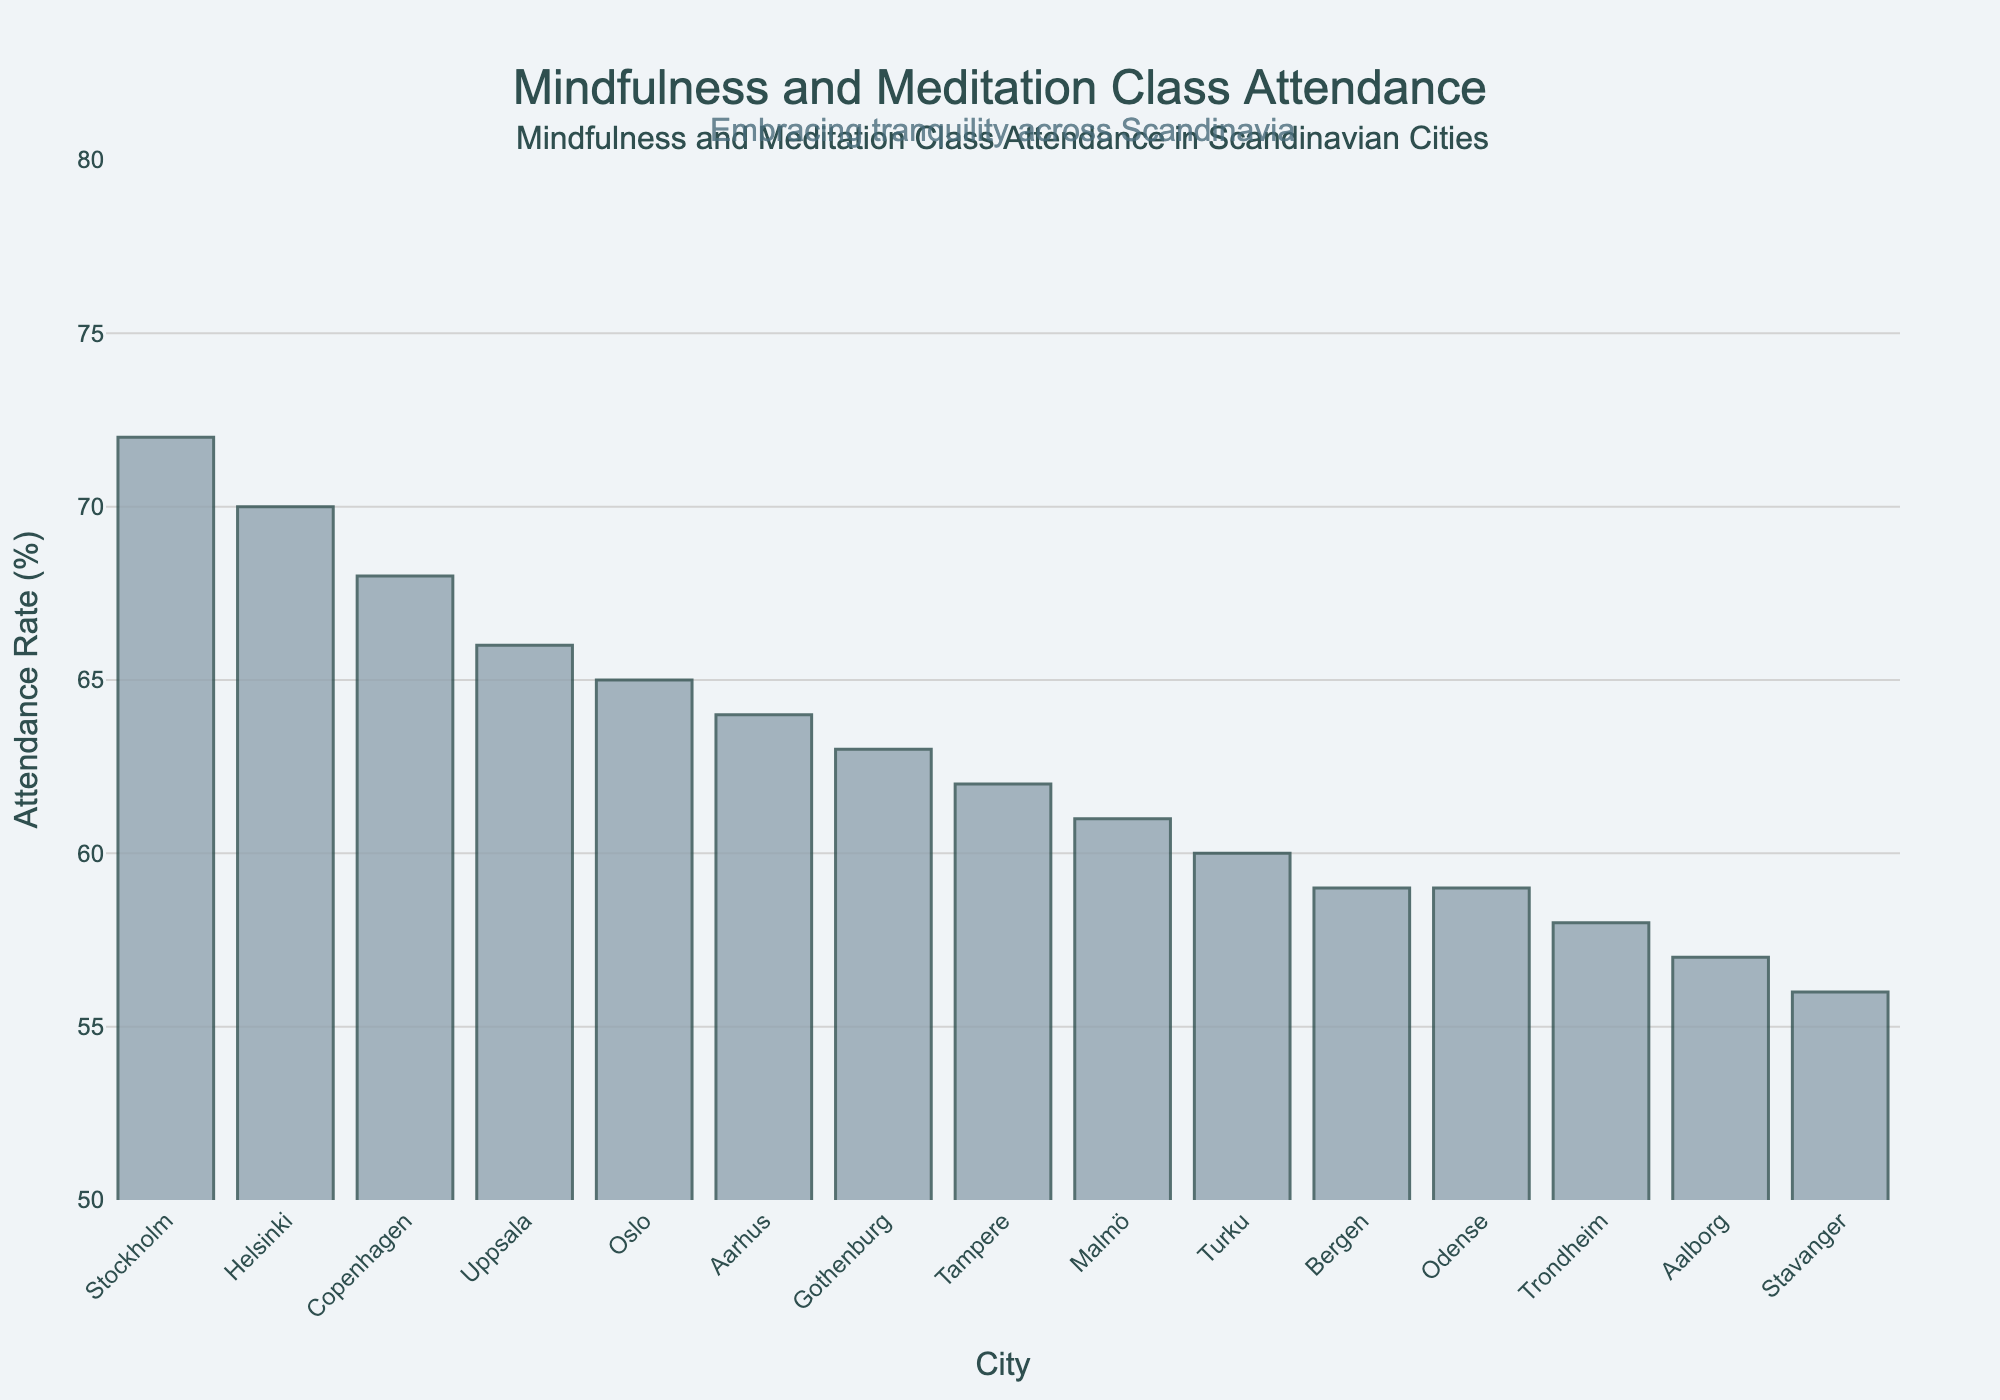Which city has the highest attendance rate? The bar that is the tallest in the figure represents the city with the highest attendance rate.
Answer: Stockholm Which city has the lowest attendance rate? The bar that is the shortest in the figure represents the city with the lowest attendance rate.
Answer: Aalborg What's the difference in attendance rate between Stockholm and Aalborg? The attendance rate for Stockholm is 72%, and for Aalborg, it is 57%. The difference is 72 - 57.
Answer: 15% Which cities have an attendance rate above 65%? The bars taller than the 65% mark represent cities with an attendance rate above 65%. These cities are identified as Copenhagen, Stockholm, Helsinki, and Uppsala.
Answer: Copenhagen, Stockholm, Helsinki, Uppsala What's the average attendance rate of the top 5 cities? The top 5 attendance rates are associated with the tallest bars: 72% (Stockholm), 70% (Helsinki), 68% (Copenhagen), 66% (Uppsala), and 65% (Oslo). The average can be calculated as (72 + 70 + 68 + 66 + 65) / 5.
Answer: 68.2% What's the median attendance rate of all cities? To find the median, first list out all 15 attendance rates in order: 56, 57, 58, 59, 59, 60, 61, 62, 63, 64, 65, 66, 68, 70, 72. The median attendance rate is the 8th value.
Answer: 62% Is there any city with an attendance rate exactly 60%? Look for the bar with an attendance rate labeled as 60%.
Answer: Turku How many cities have an attendance rate below 60%? Count the number of bars that are shorter than the 60% mark.
Answer: 4 Which cities have attendance rates between 60% and 70%? Identify the bars with heights falling between the 60% and 70% marks. These bars represent Tampere, Turku, Malmö, Gothenburg, Aarhus, and Odense.
Answer: Tampere, Turku, Malmö, Gothenburg, Aarhus, Odense 